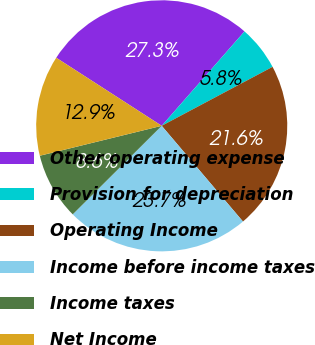<chart> <loc_0><loc_0><loc_500><loc_500><pie_chart><fcel>Other operating expense<fcel>Provision for depreciation<fcel>Operating Income<fcel>Income before income taxes<fcel>Income taxes<fcel>Net Income<nl><fcel>27.34%<fcel>5.76%<fcel>21.58%<fcel>23.74%<fcel>8.63%<fcel>12.95%<nl></chart> 